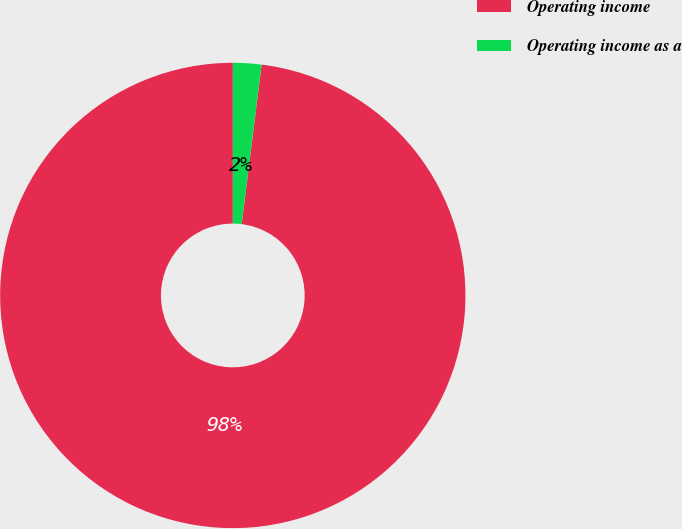Convert chart to OTSL. <chart><loc_0><loc_0><loc_500><loc_500><pie_chart><fcel>Operating income<fcel>Operating income as a<nl><fcel>98.03%<fcel>1.97%<nl></chart> 